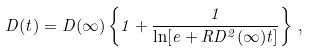Convert formula to latex. <formula><loc_0><loc_0><loc_500><loc_500>D ( t ) = D ( \infty ) \left \{ 1 + \frac { 1 } { \ln [ e + R D ^ { 2 } ( \infty ) t ] } \right \} \, ,</formula> 